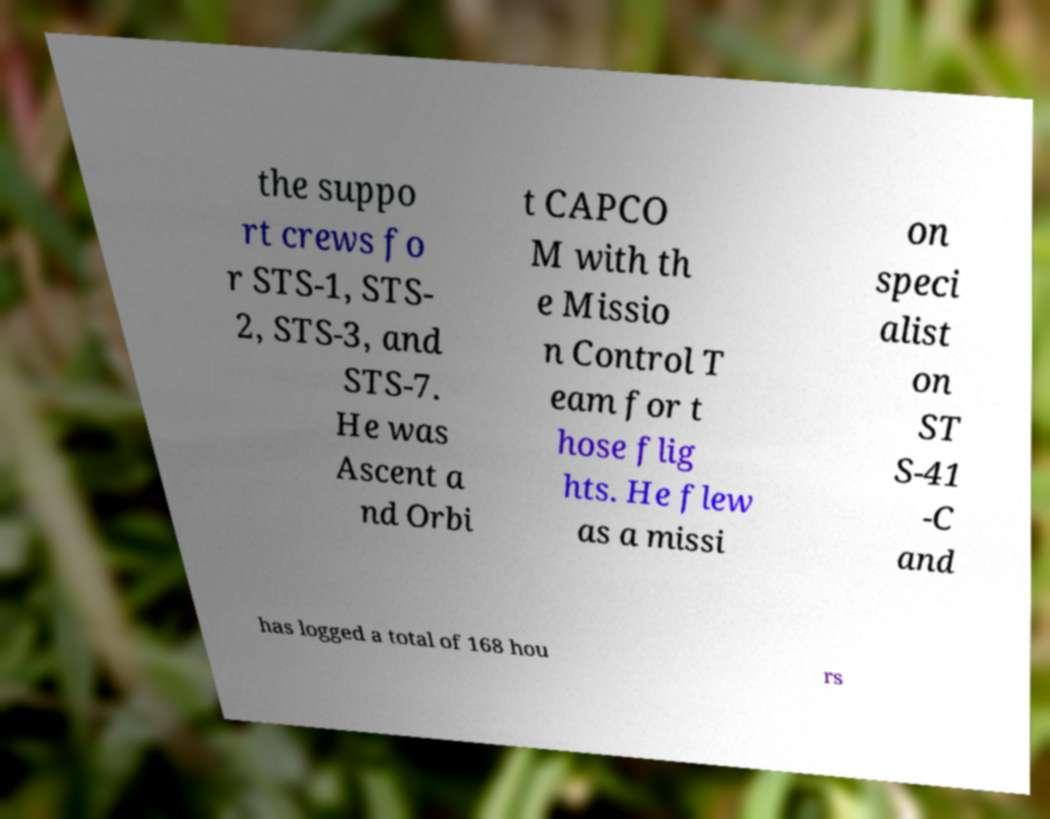I need the written content from this picture converted into text. Can you do that? the suppo rt crews fo r STS-1, STS- 2, STS-3, and STS-7. He was Ascent a nd Orbi t CAPCO M with th e Missio n Control T eam for t hose flig hts. He flew as a missi on speci alist on ST S-41 -C and has logged a total of 168 hou rs 